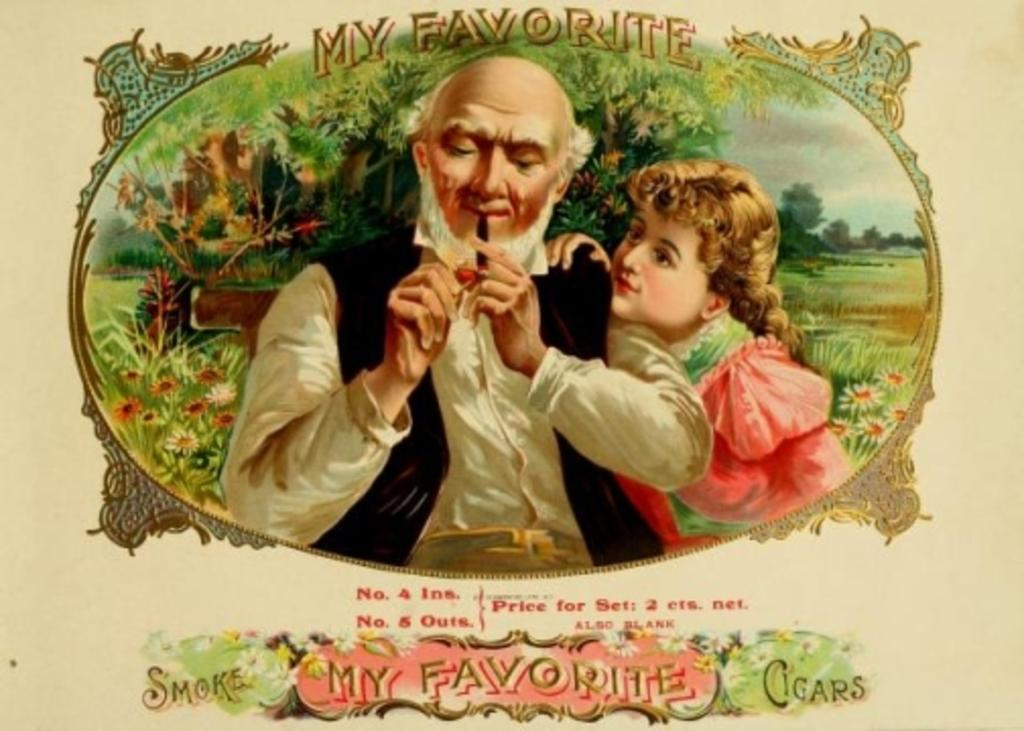<image>
Share a concise interpretation of the image provided. An advertisement for My Favorite Cigars shows a man lighting up while a young girl holds onto his shoulder watching. 